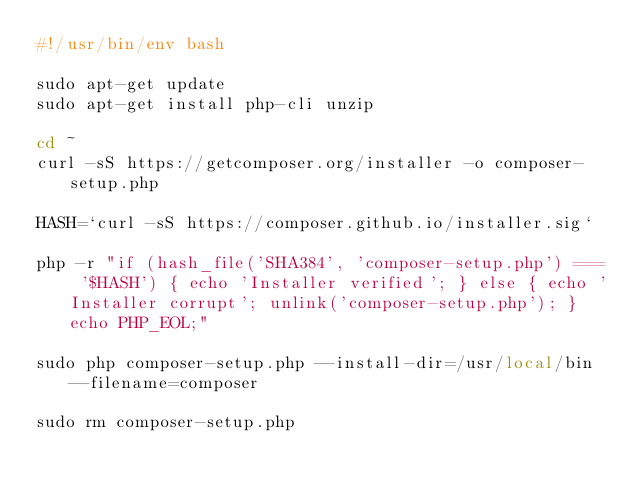<code> <loc_0><loc_0><loc_500><loc_500><_Bash_>#!/usr/bin/env bash

sudo apt-get update
sudo apt-get install php-cli unzip

cd ~
curl -sS https://getcomposer.org/installer -o composer-setup.php

HASH=`curl -sS https://composer.github.io/installer.sig`

php -r "if (hash_file('SHA384', 'composer-setup.php') === '$HASH') { echo 'Installer verified'; } else { echo 'Installer corrupt'; unlink('composer-setup.php'); } echo PHP_EOL;"

sudo php composer-setup.php --install-dir=/usr/local/bin --filename=composer

sudo rm composer-setup.php</code> 